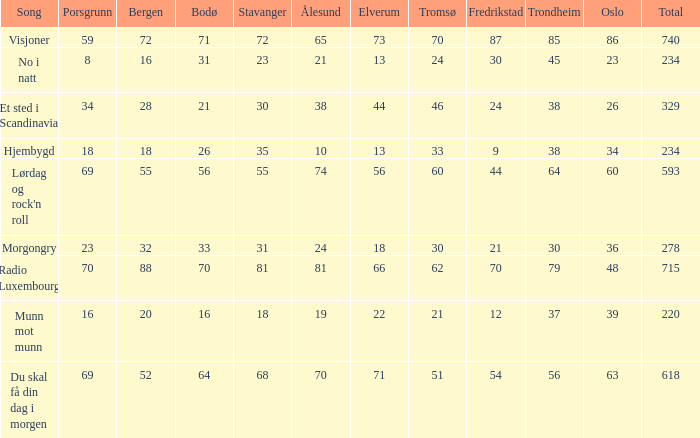When bergen is 88, what is the alesund? 81.0. 